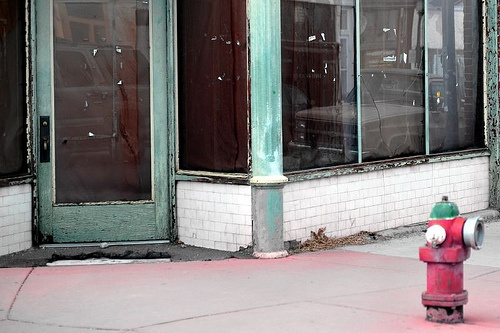Describe the objects in this image and their specific colors. I can see a fire hydrant in black, brown, salmon, and white tones in this image. 